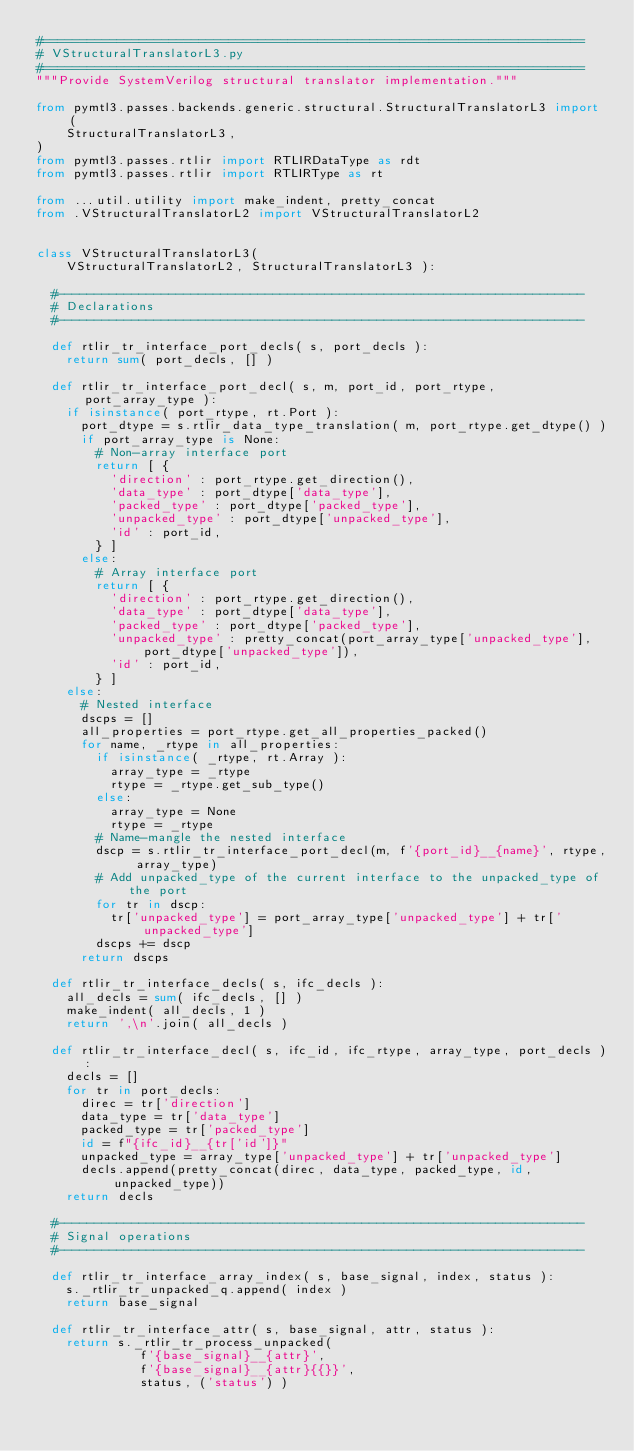Convert code to text. <code><loc_0><loc_0><loc_500><loc_500><_Python_>#=========================================================================
# VStructuralTranslatorL3.py
#=========================================================================
"""Provide SystemVerilog structural translator implementation."""

from pymtl3.passes.backends.generic.structural.StructuralTranslatorL3 import (
    StructuralTranslatorL3,
)
from pymtl3.passes.rtlir import RTLIRDataType as rdt
from pymtl3.passes.rtlir import RTLIRType as rt

from ...util.utility import make_indent, pretty_concat
from .VStructuralTranslatorL2 import VStructuralTranslatorL2


class VStructuralTranslatorL3(
    VStructuralTranslatorL2, StructuralTranslatorL3 ):

  #-----------------------------------------------------------------------
  # Declarations
  #-----------------------------------------------------------------------

  def rtlir_tr_interface_port_decls( s, port_decls ):
    return sum( port_decls, [] )

  def rtlir_tr_interface_port_decl( s, m, port_id, port_rtype, port_array_type ):
    if isinstance( port_rtype, rt.Port ):
      port_dtype = s.rtlir_data_type_translation( m, port_rtype.get_dtype() )
      if port_array_type is None:
        # Non-array interface port
        return [ {
          'direction' : port_rtype.get_direction(),
          'data_type' : port_dtype['data_type'],
          'packed_type' : port_dtype['packed_type'],
          'unpacked_type' : port_dtype['unpacked_type'],
          'id' : port_id,
        } ]
      else:
        # Array interface port
        return [ {
          'direction' : port_rtype.get_direction(),
          'data_type' : port_dtype['data_type'],
          'packed_type' : port_dtype['packed_type'],
          'unpacked_type' : pretty_concat(port_array_type['unpacked_type'], port_dtype['unpacked_type']),
          'id' : port_id,
        } ]
    else:
      # Nested interface
      dscps = []
      all_properties = port_rtype.get_all_properties_packed()
      for name, _rtype in all_properties:
        if isinstance( _rtype, rt.Array ):
          array_type = _rtype
          rtype = _rtype.get_sub_type()
        else:
          array_type = None
          rtype = _rtype
        # Name-mangle the nested interface
        dscp = s.rtlir_tr_interface_port_decl(m, f'{port_id}__{name}', rtype, array_type)
        # Add unpacked_type of the current interface to the unpacked_type of the port
        for tr in dscp:
          tr['unpacked_type'] = port_array_type['unpacked_type'] + tr['unpacked_type']
        dscps += dscp
      return dscps

  def rtlir_tr_interface_decls( s, ifc_decls ):
    all_decls = sum( ifc_decls, [] )
    make_indent( all_decls, 1 )
    return ',\n'.join( all_decls )

  def rtlir_tr_interface_decl( s, ifc_id, ifc_rtype, array_type, port_decls ):
    decls = []
    for tr in port_decls:
      direc = tr['direction']
      data_type = tr['data_type']
      packed_type = tr['packed_type']
      id = f"{ifc_id}__{tr['id']}"
      unpacked_type = array_type['unpacked_type'] + tr['unpacked_type']
      decls.append(pretty_concat(direc, data_type, packed_type, id, unpacked_type))
    return decls

  #-----------------------------------------------------------------------
  # Signal operations
  #-----------------------------------------------------------------------

  def rtlir_tr_interface_array_index( s, base_signal, index, status ):
    s._rtlir_tr_unpacked_q.append( index )
    return base_signal

  def rtlir_tr_interface_attr( s, base_signal, attr, status ):
    return s._rtlir_tr_process_unpacked(
              f'{base_signal}__{attr}',
              f'{base_signal}__{attr}{{}}',
              status, ('status') )
</code> 